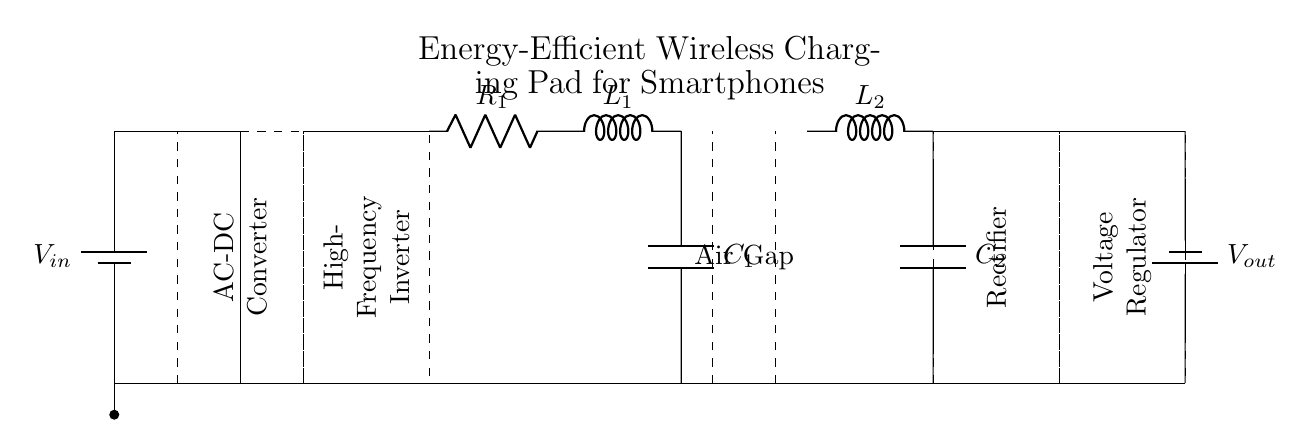What is the input voltage of the circuit? The input voltage is denoted as V_in and is indicated at the battery symbol on the left side of the diagram.
Answer: V_in What type of converter is used in the circuit? The diagram labels a component as an AC-DC Converter. This is shown as a dashed rectangle with the label inside.
Answer: AC-DC Converter What is the function of the transmitter coil? The transmitter coil, labeled with R_1, L_1, and C_1, is responsible for creating a magnetic field for wireless energy transfer. This can be deduced from its position and the function of wireless charging systems.
Answer: Energy transfer How many energy storage components are in the charging pad? There are two energy storage components: the capacitor C_1 on the transmitter side and capacitor C_2 on the receiver side. Each is clearly marked in the circuit diagram.
Answer: Two What role does the rectifier play in this circuit? The rectifier converts AC to DC voltage. This is evident because it is positioned after the coils and before the voltage regulator, indicating its function in the energy conversion process.
Answer: Converts AC to DC What is the purpose of the air gap? The air gap is crucial for separating the transmitter and receiver coils, allowing for the induction process required for wireless charging while preventing electrical contact. Its representation as two dashed lines indicates this spacing.
Answer: Induction separation 